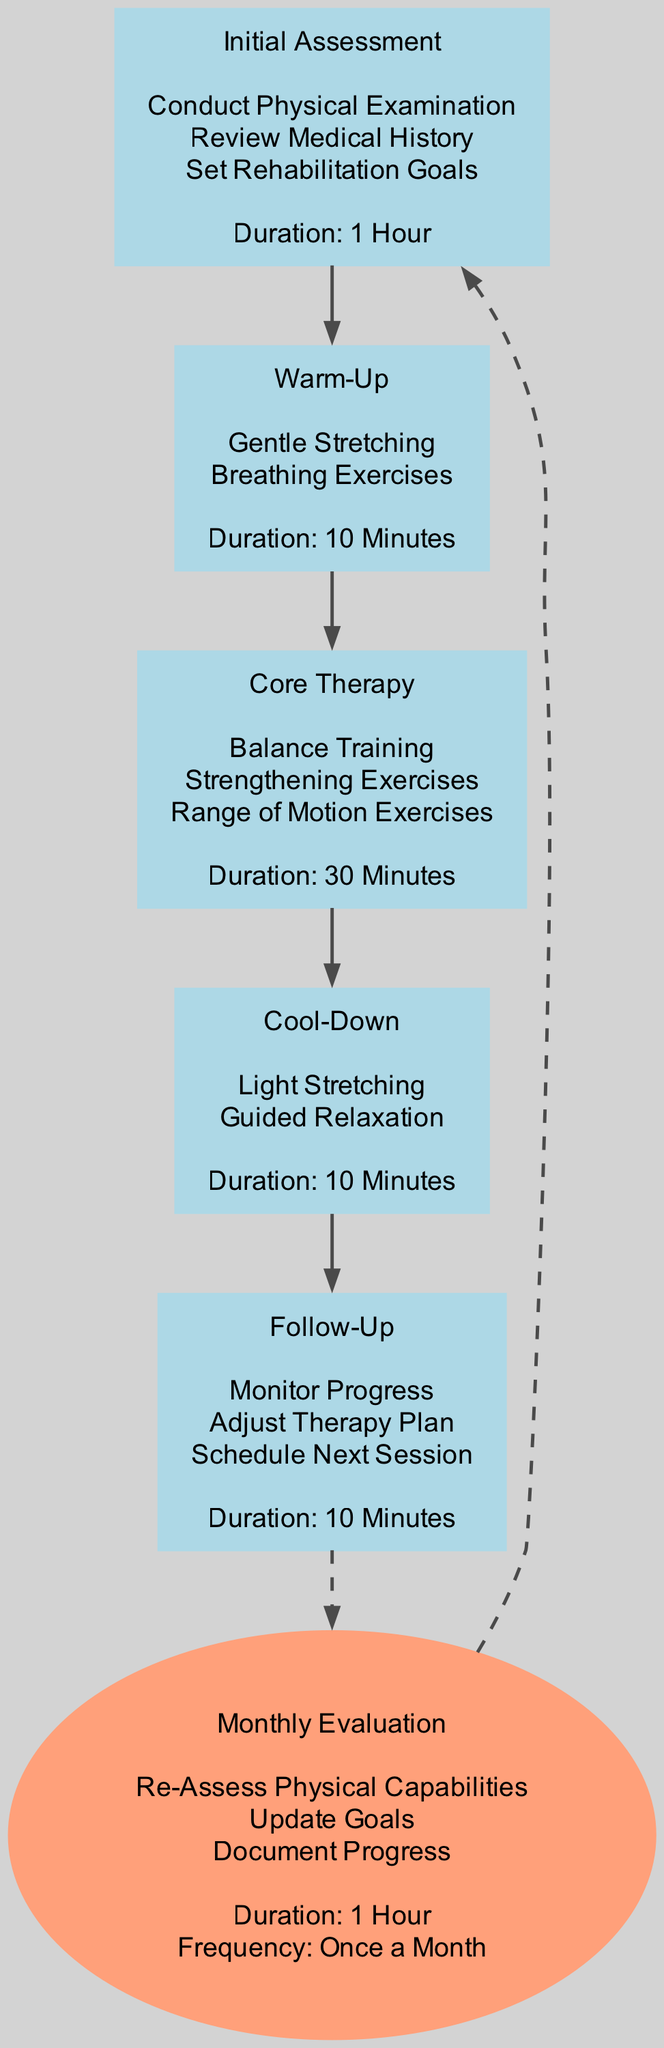What is the duration of the Initial Assessment phase? The diagram indicates that the duration of the Initial Assessment phase is shown clearly next to the phase label. It states: "Duration: 1 Hour".
Answer: 1 Hour How many activities are listed in the Core Therapy phase? By examining the Core Therapy phase in the diagram, we can see that there are three activities listed. They are "Balance Training", "Strengthening Exercises", and "Range of Motion Exercises".
Answer: 3 What are the activities included in the Cool-Down phase? The Cool-Down phase has two activities mentioned directly in the diagram: "Light Stretching" and "Guided Relaxation". These are clearly listed under the phase label.
Answer: Light Stretching, Guided Relaxation What follows after the Follow-Up phase? The diagram indicates that, following the Follow-Up phase, the Monthly Evaluation phase occurs. This is indicated by the connecting edge directed from Follow-Up to Monthly Evaluation.
Answer: Monthly Evaluation What is the frequency of the Monthly Evaluation? The frequency of the Monthly Evaluation is specified in the diagram as "Once a Month". This information is included in the label for the Monthly Evaluation phase.
Answer: Once a Month How many total phases are there before the Monthly Evaluation? The diagram lists five distinct phases before reaching the Monthly Evaluation: Initial Assessment, Warm-Up, Core Therapy, Cool-Down, and Follow-Up. Counting these phases gives us a total of five.
Answer: 5 What is the first activity listed in the Warm-Up phase? In the Warm-Up phase portion of the diagram, the first activity listed is "Gentle Stretching". This is found at the top of the activities section under that phase.
Answer: Gentle Stretching What type of connection is used between the Follow-Up and Monthly Evaluation phases? In the diagram, the connection from Follow-Up to Monthly Evaluation is represented with a dashed edge. This specific line style indicates a secondary flow to the Monthly Evaluation phase.
Answer: Dashed What is the purpose of the Initial Assessment phase? The diagram states that the purpose of the Initial Assessment phase includes conducting a physical examination, reviewing medical history, and setting rehabilitation goals. These activities outline its main objectives.
Answer: Conduct Physical Examination, Review Medical History, Set Rehabilitation Goals 